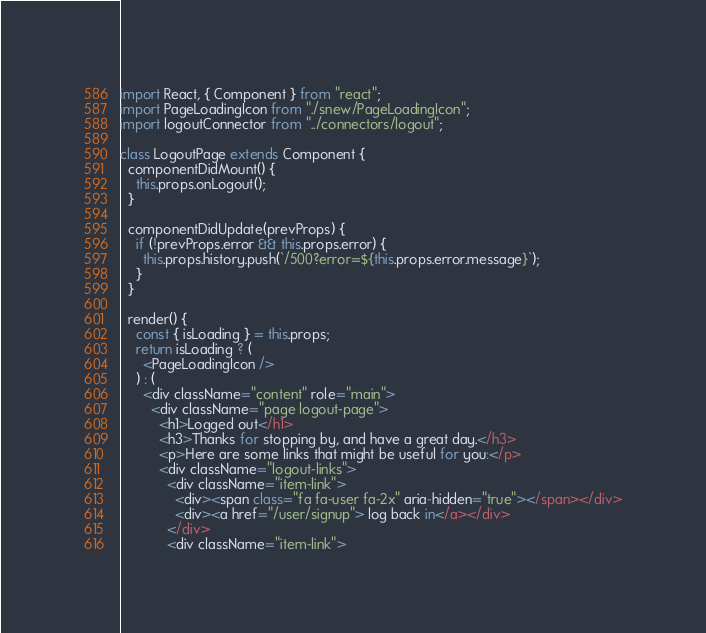Convert code to text. <code><loc_0><loc_0><loc_500><loc_500><_JavaScript_>import React, { Component } from "react";
import PageLoadingIcon from "./snew/PageLoadingIcon";
import logoutConnector from "../connectors/logout";

class LogoutPage extends Component {
  componentDidMount() {
    this.props.onLogout();
  }

  componentDidUpdate(prevProps) {
    if (!prevProps.error && this.props.error) {
      this.props.history.push(`/500?error=${this.props.error.message}`);
    }
  }

  render() {
    const { isLoading } = this.props;
    return isLoading ? (
      <PageLoadingIcon />
    ) : (
      <div className="content" role="main">
        <div className="page logout-page">
          <h1>Logged out</h1>
          <h3>Thanks for stopping by, and have a great day.</h3>
          <p>Here are some links that might be useful for you:</p>
          <div className="logout-links">
            <div className="item-link">
              <div><span class="fa fa-user fa-2x" aria-hidden="true"></span></div>
              <div><a href="/user/signup"> log back in</a></div>
            </div>
            <div className="item-link"></code> 